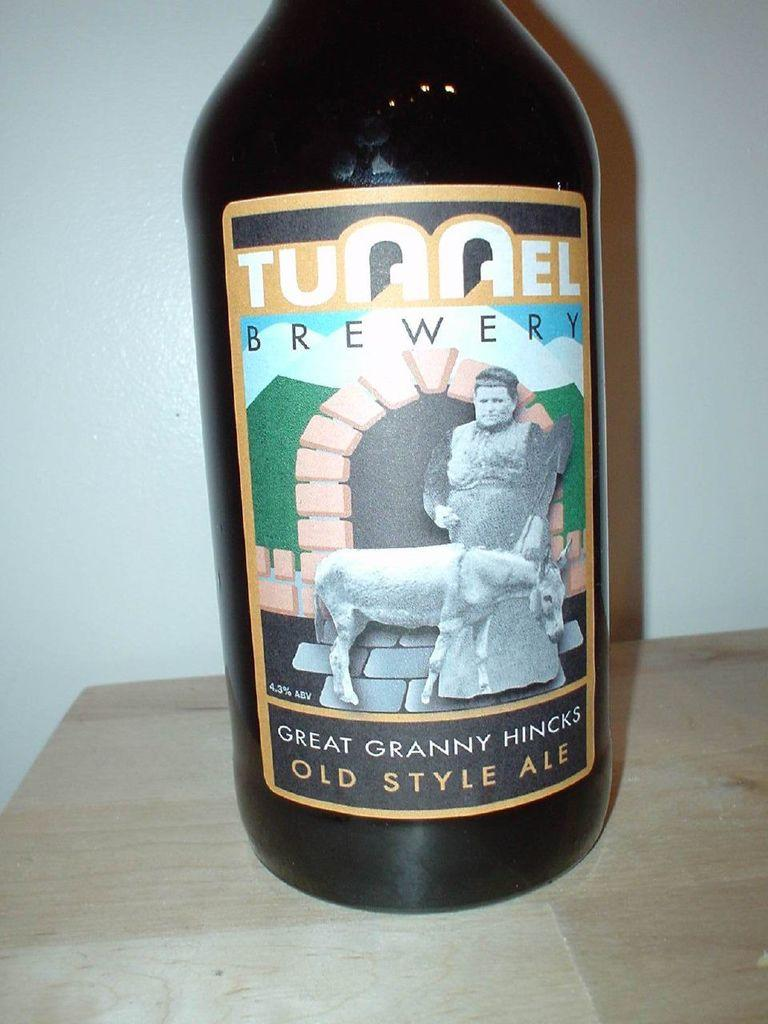<image>
Provide a brief description of the given image. the word brewery that is on a bottle 